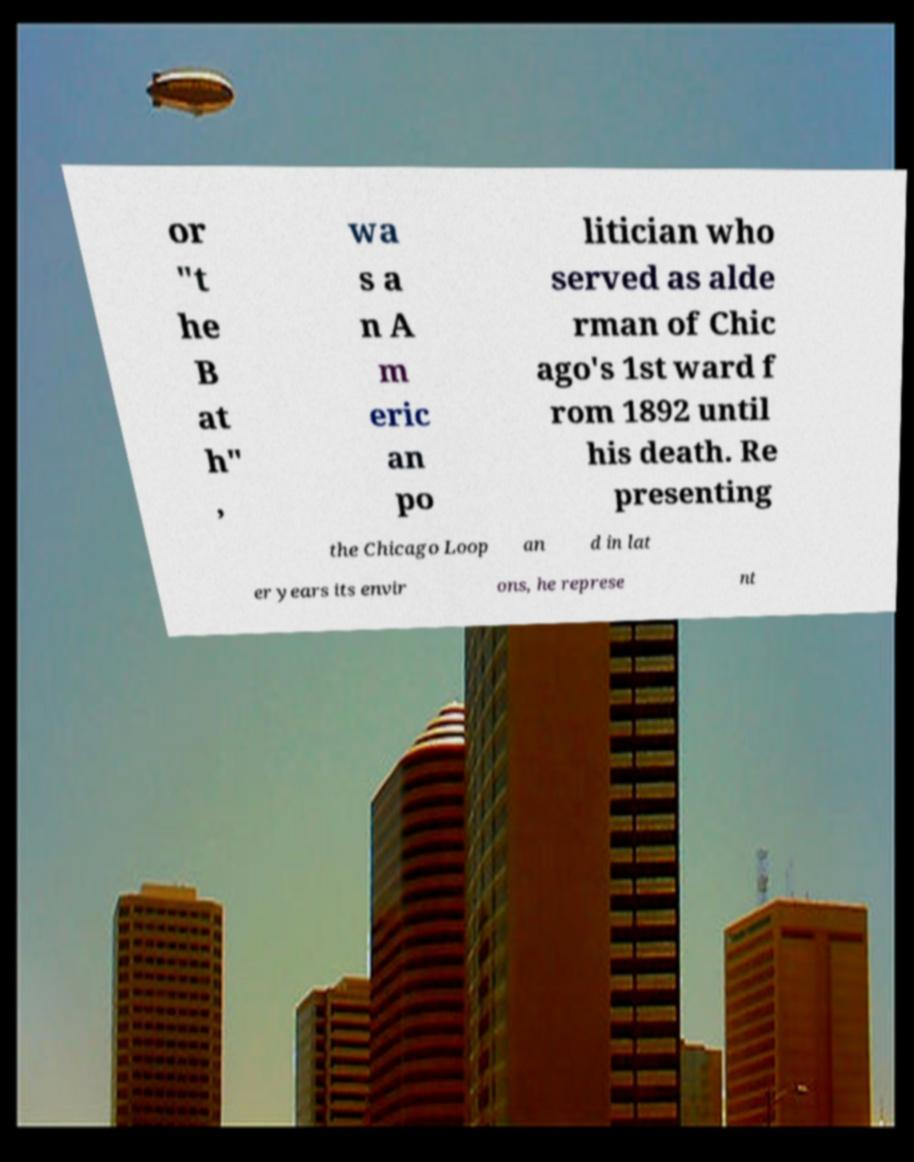Could you extract and type out the text from this image? or "t he B at h" , wa s a n A m eric an po litician who served as alde rman of Chic ago's 1st ward f rom 1892 until his death. Re presenting the Chicago Loop an d in lat er years its envir ons, he represe nt 